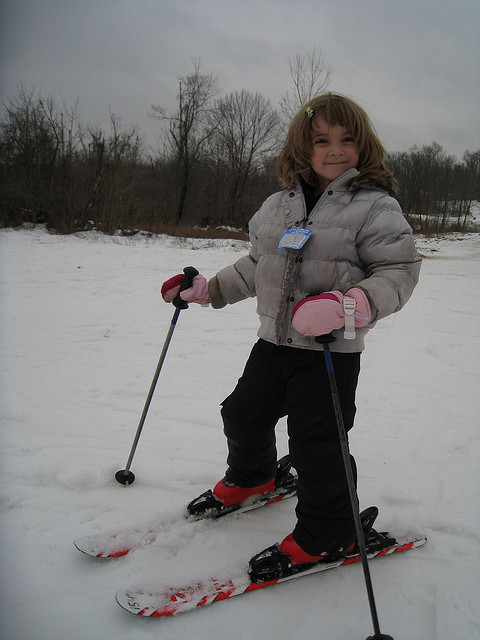How does the weather appear to be in the image? The sky looks overcast, and there's snow on the ground, suggesting cold and cloudy weather conditions, typical for a winter day. 